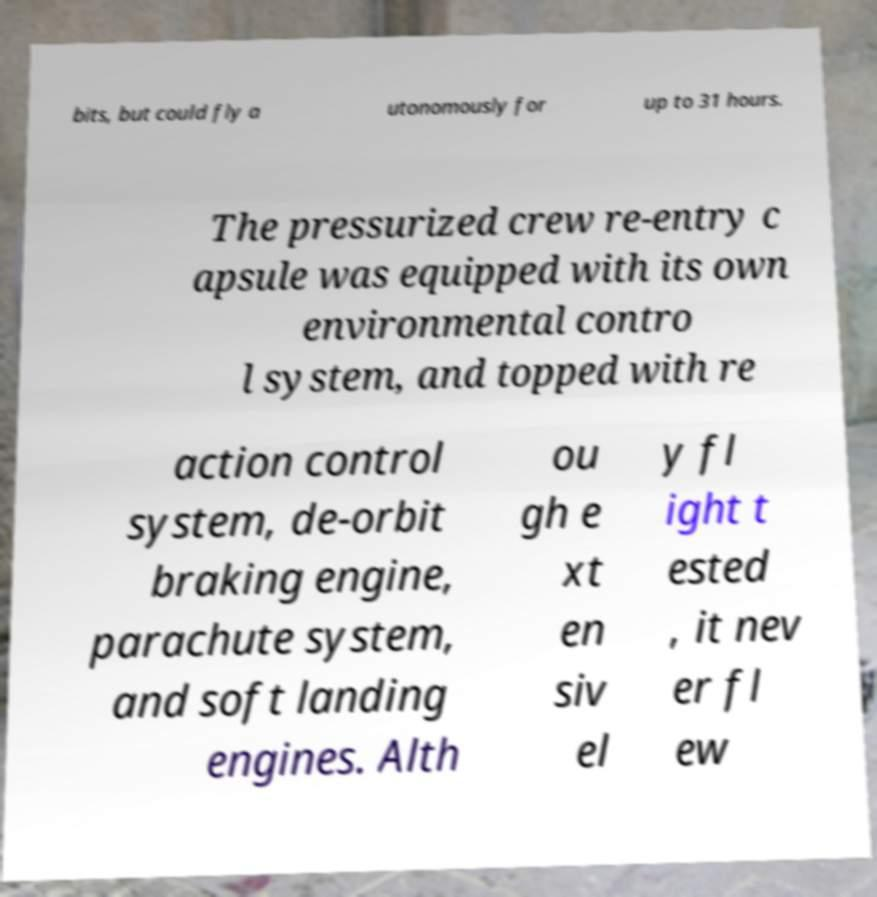For documentation purposes, I need the text within this image transcribed. Could you provide that? bits, but could fly a utonomously for up to 31 hours. The pressurized crew re-entry c apsule was equipped with its own environmental contro l system, and topped with re action control system, de-orbit braking engine, parachute system, and soft landing engines. Alth ou gh e xt en siv el y fl ight t ested , it nev er fl ew 